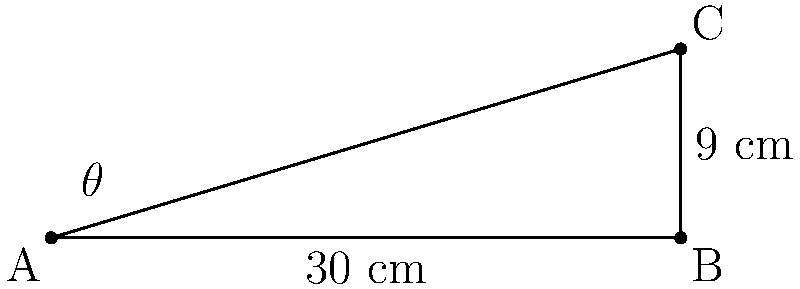You're designing a new cake stand for a wedding display. The stand needs to be inclined to create a visually appealing presentation. If the base of the stand is 30 cm long and the raised end is 9 cm high, what is the angle of inclination ($\theta$) of the cake stand? To find the angle of inclination, we can use trigonometry. Let's approach this step-by-step:

1) The cake stand forms a right-angled triangle, where:
   - The base (adjacent side) is 30 cm
   - The height (opposite side) is 9 cm
   - The angle we're looking for is $\theta$

2) In a right-angled triangle, $\tan(\theta) = \frac{\text{opposite}}{\text{adjacent}}$

3) Substituting our values:
   $\tan(\theta) = \frac{9}{30} = \frac{3}{10} = 0.3$

4) To find $\theta$, we need to use the inverse tangent (arctan or $\tan^{-1}$):
   $\theta = \tan^{-1}(0.3)$

5) Using a calculator or trigonometric tables:
   $\theta \approx 16.7°$

6) For baking purposes, we can round this to the nearest degree:
   $\theta \approx 17°$
Answer: $17°$ 